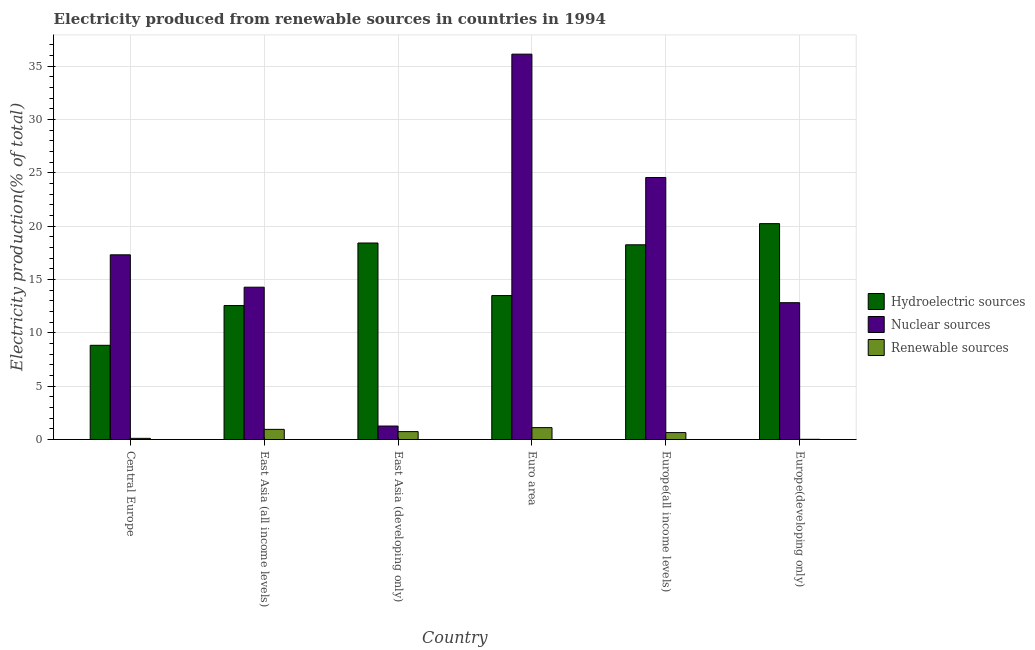How many different coloured bars are there?
Provide a short and direct response. 3. How many groups of bars are there?
Your response must be concise. 6. Are the number of bars per tick equal to the number of legend labels?
Provide a short and direct response. Yes. Are the number of bars on each tick of the X-axis equal?
Give a very brief answer. Yes. How many bars are there on the 2nd tick from the left?
Your answer should be compact. 3. What is the label of the 5th group of bars from the left?
Give a very brief answer. Europe(all income levels). What is the percentage of electricity produced by nuclear sources in East Asia (all income levels)?
Ensure brevity in your answer.  14.28. Across all countries, what is the maximum percentage of electricity produced by nuclear sources?
Your answer should be compact. 36.13. Across all countries, what is the minimum percentage of electricity produced by hydroelectric sources?
Ensure brevity in your answer.  8.83. In which country was the percentage of electricity produced by nuclear sources minimum?
Provide a short and direct response. East Asia (developing only). What is the total percentage of electricity produced by renewable sources in the graph?
Give a very brief answer. 3.59. What is the difference between the percentage of electricity produced by nuclear sources in East Asia (developing only) and that in Euro area?
Provide a succinct answer. -34.87. What is the difference between the percentage of electricity produced by nuclear sources in East Asia (developing only) and the percentage of electricity produced by renewable sources in East Asia (all income levels)?
Ensure brevity in your answer.  0.31. What is the average percentage of electricity produced by hydroelectric sources per country?
Give a very brief answer. 15.3. What is the difference between the percentage of electricity produced by nuclear sources and percentage of electricity produced by hydroelectric sources in Europe(developing only)?
Offer a very short reply. -7.41. What is the ratio of the percentage of electricity produced by renewable sources in Central Europe to that in Europe(developing only)?
Your response must be concise. 5.5. What is the difference between the highest and the second highest percentage of electricity produced by renewable sources?
Provide a succinct answer. 0.16. What is the difference between the highest and the lowest percentage of electricity produced by renewable sources?
Provide a short and direct response. 1.09. In how many countries, is the percentage of electricity produced by nuclear sources greater than the average percentage of electricity produced by nuclear sources taken over all countries?
Offer a terse response. 2. What does the 3rd bar from the left in East Asia (all income levels) represents?
Keep it short and to the point. Renewable sources. What does the 1st bar from the right in Central Europe represents?
Your answer should be compact. Renewable sources. Is it the case that in every country, the sum of the percentage of electricity produced by hydroelectric sources and percentage of electricity produced by nuclear sources is greater than the percentage of electricity produced by renewable sources?
Provide a short and direct response. Yes. Are all the bars in the graph horizontal?
Offer a terse response. No. Are the values on the major ticks of Y-axis written in scientific E-notation?
Ensure brevity in your answer.  No. Does the graph contain any zero values?
Offer a terse response. No. Does the graph contain grids?
Make the answer very short. Yes. Where does the legend appear in the graph?
Provide a succinct answer. Center right. How are the legend labels stacked?
Make the answer very short. Vertical. What is the title of the graph?
Ensure brevity in your answer.  Electricity produced from renewable sources in countries in 1994. Does "Domestic economy" appear as one of the legend labels in the graph?
Your response must be concise. No. What is the label or title of the Y-axis?
Provide a succinct answer. Electricity production(% of total). What is the Electricity production(% of total) of Hydroelectric sources in Central Europe?
Make the answer very short. 8.83. What is the Electricity production(% of total) of Nuclear sources in Central Europe?
Offer a very short reply. 17.32. What is the Electricity production(% of total) in Renewable sources in Central Europe?
Offer a very short reply. 0.11. What is the Electricity production(% of total) of Hydroelectric sources in East Asia (all income levels)?
Your answer should be very brief. 12.56. What is the Electricity production(% of total) of Nuclear sources in East Asia (all income levels)?
Keep it short and to the point. 14.28. What is the Electricity production(% of total) in Renewable sources in East Asia (all income levels)?
Offer a terse response. 0.95. What is the Electricity production(% of total) in Hydroelectric sources in East Asia (developing only)?
Provide a succinct answer. 18.43. What is the Electricity production(% of total) of Nuclear sources in East Asia (developing only)?
Your answer should be compact. 1.26. What is the Electricity production(% of total) of Renewable sources in East Asia (developing only)?
Offer a terse response. 0.74. What is the Electricity production(% of total) in Hydroelectric sources in Euro area?
Make the answer very short. 13.5. What is the Electricity production(% of total) in Nuclear sources in Euro area?
Give a very brief answer. 36.13. What is the Electricity production(% of total) of Renewable sources in Euro area?
Offer a terse response. 1.11. What is the Electricity production(% of total) of Hydroelectric sources in Europe(all income levels)?
Offer a terse response. 18.26. What is the Electricity production(% of total) of Nuclear sources in Europe(all income levels)?
Ensure brevity in your answer.  24.57. What is the Electricity production(% of total) in Renewable sources in Europe(all income levels)?
Offer a very short reply. 0.65. What is the Electricity production(% of total) in Hydroelectric sources in Europe(developing only)?
Keep it short and to the point. 20.24. What is the Electricity production(% of total) of Nuclear sources in Europe(developing only)?
Ensure brevity in your answer.  12.83. What is the Electricity production(% of total) of Renewable sources in Europe(developing only)?
Provide a short and direct response. 0.02. Across all countries, what is the maximum Electricity production(% of total) in Hydroelectric sources?
Offer a terse response. 20.24. Across all countries, what is the maximum Electricity production(% of total) of Nuclear sources?
Your response must be concise. 36.13. Across all countries, what is the maximum Electricity production(% of total) in Renewable sources?
Provide a succinct answer. 1.11. Across all countries, what is the minimum Electricity production(% of total) in Hydroelectric sources?
Provide a short and direct response. 8.83. Across all countries, what is the minimum Electricity production(% of total) of Nuclear sources?
Your response must be concise. 1.26. Across all countries, what is the minimum Electricity production(% of total) in Renewable sources?
Keep it short and to the point. 0.02. What is the total Electricity production(% of total) in Hydroelectric sources in the graph?
Provide a short and direct response. 91.82. What is the total Electricity production(% of total) in Nuclear sources in the graph?
Your response must be concise. 106.4. What is the total Electricity production(% of total) of Renewable sources in the graph?
Your answer should be compact. 3.59. What is the difference between the Electricity production(% of total) in Hydroelectric sources in Central Europe and that in East Asia (all income levels)?
Make the answer very short. -3.73. What is the difference between the Electricity production(% of total) of Nuclear sources in Central Europe and that in East Asia (all income levels)?
Keep it short and to the point. 3.04. What is the difference between the Electricity production(% of total) of Renewable sources in Central Europe and that in East Asia (all income levels)?
Give a very brief answer. -0.84. What is the difference between the Electricity production(% of total) in Hydroelectric sources in Central Europe and that in East Asia (developing only)?
Keep it short and to the point. -9.59. What is the difference between the Electricity production(% of total) of Nuclear sources in Central Europe and that in East Asia (developing only)?
Provide a succinct answer. 16.05. What is the difference between the Electricity production(% of total) of Renewable sources in Central Europe and that in East Asia (developing only)?
Your answer should be compact. -0.63. What is the difference between the Electricity production(% of total) in Hydroelectric sources in Central Europe and that in Euro area?
Give a very brief answer. -4.66. What is the difference between the Electricity production(% of total) in Nuclear sources in Central Europe and that in Euro area?
Keep it short and to the point. -18.82. What is the difference between the Electricity production(% of total) in Renewable sources in Central Europe and that in Euro area?
Provide a succinct answer. -1.01. What is the difference between the Electricity production(% of total) in Hydroelectric sources in Central Europe and that in Europe(all income levels)?
Provide a short and direct response. -9.43. What is the difference between the Electricity production(% of total) in Nuclear sources in Central Europe and that in Europe(all income levels)?
Give a very brief answer. -7.25. What is the difference between the Electricity production(% of total) of Renewable sources in Central Europe and that in Europe(all income levels)?
Make the answer very short. -0.54. What is the difference between the Electricity production(% of total) of Hydroelectric sources in Central Europe and that in Europe(developing only)?
Keep it short and to the point. -11.41. What is the difference between the Electricity production(% of total) of Nuclear sources in Central Europe and that in Europe(developing only)?
Ensure brevity in your answer.  4.49. What is the difference between the Electricity production(% of total) of Renewable sources in Central Europe and that in Europe(developing only)?
Your response must be concise. 0.09. What is the difference between the Electricity production(% of total) in Hydroelectric sources in East Asia (all income levels) and that in East Asia (developing only)?
Provide a short and direct response. -5.86. What is the difference between the Electricity production(% of total) of Nuclear sources in East Asia (all income levels) and that in East Asia (developing only)?
Offer a terse response. 13.02. What is the difference between the Electricity production(% of total) in Renewable sources in East Asia (all income levels) and that in East Asia (developing only)?
Offer a terse response. 0.21. What is the difference between the Electricity production(% of total) in Hydroelectric sources in East Asia (all income levels) and that in Euro area?
Your answer should be very brief. -0.94. What is the difference between the Electricity production(% of total) of Nuclear sources in East Asia (all income levels) and that in Euro area?
Your answer should be compact. -21.85. What is the difference between the Electricity production(% of total) in Renewable sources in East Asia (all income levels) and that in Euro area?
Provide a short and direct response. -0.16. What is the difference between the Electricity production(% of total) of Hydroelectric sources in East Asia (all income levels) and that in Europe(all income levels)?
Your answer should be very brief. -5.7. What is the difference between the Electricity production(% of total) of Nuclear sources in East Asia (all income levels) and that in Europe(all income levels)?
Provide a short and direct response. -10.29. What is the difference between the Electricity production(% of total) of Renewable sources in East Asia (all income levels) and that in Europe(all income levels)?
Provide a short and direct response. 0.3. What is the difference between the Electricity production(% of total) in Hydroelectric sources in East Asia (all income levels) and that in Europe(developing only)?
Offer a terse response. -7.68. What is the difference between the Electricity production(% of total) in Nuclear sources in East Asia (all income levels) and that in Europe(developing only)?
Make the answer very short. 1.45. What is the difference between the Electricity production(% of total) of Renewable sources in East Asia (all income levels) and that in Europe(developing only)?
Provide a succinct answer. 0.93. What is the difference between the Electricity production(% of total) in Hydroelectric sources in East Asia (developing only) and that in Euro area?
Provide a short and direct response. 4.93. What is the difference between the Electricity production(% of total) in Nuclear sources in East Asia (developing only) and that in Euro area?
Provide a succinct answer. -34.87. What is the difference between the Electricity production(% of total) of Renewable sources in East Asia (developing only) and that in Euro area?
Provide a succinct answer. -0.37. What is the difference between the Electricity production(% of total) in Hydroelectric sources in East Asia (developing only) and that in Europe(all income levels)?
Keep it short and to the point. 0.17. What is the difference between the Electricity production(% of total) in Nuclear sources in East Asia (developing only) and that in Europe(all income levels)?
Offer a terse response. -23.3. What is the difference between the Electricity production(% of total) of Renewable sources in East Asia (developing only) and that in Europe(all income levels)?
Provide a short and direct response. 0.09. What is the difference between the Electricity production(% of total) in Hydroelectric sources in East Asia (developing only) and that in Europe(developing only)?
Provide a succinct answer. -1.81. What is the difference between the Electricity production(% of total) of Nuclear sources in East Asia (developing only) and that in Europe(developing only)?
Give a very brief answer. -11.57. What is the difference between the Electricity production(% of total) in Renewable sources in East Asia (developing only) and that in Europe(developing only)?
Give a very brief answer. 0.72. What is the difference between the Electricity production(% of total) of Hydroelectric sources in Euro area and that in Europe(all income levels)?
Ensure brevity in your answer.  -4.76. What is the difference between the Electricity production(% of total) in Nuclear sources in Euro area and that in Europe(all income levels)?
Ensure brevity in your answer.  11.57. What is the difference between the Electricity production(% of total) in Renewable sources in Euro area and that in Europe(all income levels)?
Keep it short and to the point. 0.46. What is the difference between the Electricity production(% of total) of Hydroelectric sources in Euro area and that in Europe(developing only)?
Give a very brief answer. -6.74. What is the difference between the Electricity production(% of total) in Nuclear sources in Euro area and that in Europe(developing only)?
Provide a succinct answer. 23.3. What is the difference between the Electricity production(% of total) of Renewable sources in Euro area and that in Europe(developing only)?
Offer a very short reply. 1.09. What is the difference between the Electricity production(% of total) in Hydroelectric sources in Europe(all income levels) and that in Europe(developing only)?
Provide a succinct answer. -1.98. What is the difference between the Electricity production(% of total) of Nuclear sources in Europe(all income levels) and that in Europe(developing only)?
Ensure brevity in your answer.  11.74. What is the difference between the Electricity production(% of total) in Renewable sources in Europe(all income levels) and that in Europe(developing only)?
Ensure brevity in your answer.  0.63. What is the difference between the Electricity production(% of total) in Hydroelectric sources in Central Europe and the Electricity production(% of total) in Nuclear sources in East Asia (all income levels)?
Your answer should be compact. -5.45. What is the difference between the Electricity production(% of total) in Hydroelectric sources in Central Europe and the Electricity production(% of total) in Renewable sources in East Asia (all income levels)?
Provide a succinct answer. 7.88. What is the difference between the Electricity production(% of total) in Nuclear sources in Central Europe and the Electricity production(% of total) in Renewable sources in East Asia (all income levels)?
Your answer should be compact. 16.37. What is the difference between the Electricity production(% of total) in Hydroelectric sources in Central Europe and the Electricity production(% of total) in Nuclear sources in East Asia (developing only)?
Offer a terse response. 7.57. What is the difference between the Electricity production(% of total) of Hydroelectric sources in Central Europe and the Electricity production(% of total) of Renewable sources in East Asia (developing only)?
Your response must be concise. 8.09. What is the difference between the Electricity production(% of total) of Nuclear sources in Central Europe and the Electricity production(% of total) of Renewable sources in East Asia (developing only)?
Provide a succinct answer. 16.58. What is the difference between the Electricity production(% of total) in Hydroelectric sources in Central Europe and the Electricity production(% of total) in Nuclear sources in Euro area?
Provide a succinct answer. -27.3. What is the difference between the Electricity production(% of total) of Hydroelectric sources in Central Europe and the Electricity production(% of total) of Renewable sources in Euro area?
Provide a succinct answer. 7.72. What is the difference between the Electricity production(% of total) in Nuclear sources in Central Europe and the Electricity production(% of total) in Renewable sources in Euro area?
Your response must be concise. 16.2. What is the difference between the Electricity production(% of total) of Hydroelectric sources in Central Europe and the Electricity production(% of total) of Nuclear sources in Europe(all income levels)?
Offer a terse response. -15.73. What is the difference between the Electricity production(% of total) of Hydroelectric sources in Central Europe and the Electricity production(% of total) of Renewable sources in Europe(all income levels)?
Your answer should be compact. 8.18. What is the difference between the Electricity production(% of total) of Nuclear sources in Central Europe and the Electricity production(% of total) of Renewable sources in Europe(all income levels)?
Your response must be concise. 16.67. What is the difference between the Electricity production(% of total) of Hydroelectric sources in Central Europe and the Electricity production(% of total) of Nuclear sources in Europe(developing only)?
Give a very brief answer. -4. What is the difference between the Electricity production(% of total) of Hydroelectric sources in Central Europe and the Electricity production(% of total) of Renewable sources in Europe(developing only)?
Your response must be concise. 8.81. What is the difference between the Electricity production(% of total) in Nuclear sources in Central Europe and the Electricity production(% of total) in Renewable sources in Europe(developing only)?
Ensure brevity in your answer.  17.3. What is the difference between the Electricity production(% of total) in Hydroelectric sources in East Asia (all income levels) and the Electricity production(% of total) in Nuclear sources in East Asia (developing only)?
Provide a succinct answer. 11.3. What is the difference between the Electricity production(% of total) in Hydroelectric sources in East Asia (all income levels) and the Electricity production(% of total) in Renewable sources in East Asia (developing only)?
Ensure brevity in your answer.  11.82. What is the difference between the Electricity production(% of total) of Nuclear sources in East Asia (all income levels) and the Electricity production(% of total) of Renewable sources in East Asia (developing only)?
Ensure brevity in your answer.  13.54. What is the difference between the Electricity production(% of total) of Hydroelectric sources in East Asia (all income levels) and the Electricity production(% of total) of Nuclear sources in Euro area?
Your answer should be compact. -23.57. What is the difference between the Electricity production(% of total) of Hydroelectric sources in East Asia (all income levels) and the Electricity production(% of total) of Renewable sources in Euro area?
Provide a short and direct response. 11.45. What is the difference between the Electricity production(% of total) in Nuclear sources in East Asia (all income levels) and the Electricity production(% of total) in Renewable sources in Euro area?
Give a very brief answer. 13.17. What is the difference between the Electricity production(% of total) in Hydroelectric sources in East Asia (all income levels) and the Electricity production(% of total) in Nuclear sources in Europe(all income levels)?
Offer a terse response. -12.01. What is the difference between the Electricity production(% of total) in Hydroelectric sources in East Asia (all income levels) and the Electricity production(% of total) in Renewable sources in Europe(all income levels)?
Give a very brief answer. 11.91. What is the difference between the Electricity production(% of total) in Nuclear sources in East Asia (all income levels) and the Electricity production(% of total) in Renewable sources in Europe(all income levels)?
Offer a very short reply. 13.63. What is the difference between the Electricity production(% of total) of Hydroelectric sources in East Asia (all income levels) and the Electricity production(% of total) of Nuclear sources in Europe(developing only)?
Offer a terse response. -0.27. What is the difference between the Electricity production(% of total) in Hydroelectric sources in East Asia (all income levels) and the Electricity production(% of total) in Renewable sources in Europe(developing only)?
Offer a very short reply. 12.54. What is the difference between the Electricity production(% of total) in Nuclear sources in East Asia (all income levels) and the Electricity production(% of total) in Renewable sources in Europe(developing only)?
Your answer should be very brief. 14.26. What is the difference between the Electricity production(% of total) of Hydroelectric sources in East Asia (developing only) and the Electricity production(% of total) of Nuclear sources in Euro area?
Provide a succinct answer. -17.71. What is the difference between the Electricity production(% of total) of Hydroelectric sources in East Asia (developing only) and the Electricity production(% of total) of Renewable sources in Euro area?
Ensure brevity in your answer.  17.31. What is the difference between the Electricity production(% of total) of Nuclear sources in East Asia (developing only) and the Electricity production(% of total) of Renewable sources in Euro area?
Offer a very short reply. 0.15. What is the difference between the Electricity production(% of total) in Hydroelectric sources in East Asia (developing only) and the Electricity production(% of total) in Nuclear sources in Europe(all income levels)?
Keep it short and to the point. -6.14. What is the difference between the Electricity production(% of total) in Hydroelectric sources in East Asia (developing only) and the Electricity production(% of total) in Renewable sources in Europe(all income levels)?
Provide a short and direct response. 17.78. What is the difference between the Electricity production(% of total) of Nuclear sources in East Asia (developing only) and the Electricity production(% of total) of Renewable sources in Europe(all income levels)?
Your answer should be very brief. 0.61. What is the difference between the Electricity production(% of total) of Hydroelectric sources in East Asia (developing only) and the Electricity production(% of total) of Nuclear sources in Europe(developing only)?
Keep it short and to the point. 5.6. What is the difference between the Electricity production(% of total) in Hydroelectric sources in East Asia (developing only) and the Electricity production(% of total) in Renewable sources in Europe(developing only)?
Provide a short and direct response. 18.41. What is the difference between the Electricity production(% of total) in Nuclear sources in East Asia (developing only) and the Electricity production(% of total) in Renewable sources in Europe(developing only)?
Keep it short and to the point. 1.24. What is the difference between the Electricity production(% of total) of Hydroelectric sources in Euro area and the Electricity production(% of total) of Nuclear sources in Europe(all income levels)?
Ensure brevity in your answer.  -11.07. What is the difference between the Electricity production(% of total) of Hydroelectric sources in Euro area and the Electricity production(% of total) of Renewable sources in Europe(all income levels)?
Offer a very short reply. 12.85. What is the difference between the Electricity production(% of total) in Nuclear sources in Euro area and the Electricity production(% of total) in Renewable sources in Europe(all income levels)?
Your answer should be compact. 35.48. What is the difference between the Electricity production(% of total) in Hydroelectric sources in Euro area and the Electricity production(% of total) in Nuclear sources in Europe(developing only)?
Offer a very short reply. 0.67. What is the difference between the Electricity production(% of total) in Hydroelectric sources in Euro area and the Electricity production(% of total) in Renewable sources in Europe(developing only)?
Your answer should be compact. 13.48. What is the difference between the Electricity production(% of total) in Nuclear sources in Euro area and the Electricity production(% of total) in Renewable sources in Europe(developing only)?
Your answer should be compact. 36.11. What is the difference between the Electricity production(% of total) of Hydroelectric sources in Europe(all income levels) and the Electricity production(% of total) of Nuclear sources in Europe(developing only)?
Your answer should be very brief. 5.43. What is the difference between the Electricity production(% of total) of Hydroelectric sources in Europe(all income levels) and the Electricity production(% of total) of Renewable sources in Europe(developing only)?
Ensure brevity in your answer.  18.24. What is the difference between the Electricity production(% of total) in Nuclear sources in Europe(all income levels) and the Electricity production(% of total) in Renewable sources in Europe(developing only)?
Give a very brief answer. 24.55. What is the average Electricity production(% of total) in Hydroelectric sources per country?
Keep it short and to the point. 15.3. What is the average Electricity production(% of total) in Nuclear sources per country?
Your answer should be very brief. 17.73. What is the average Electricity production(% of total) in Renewable sources per country?
Make the answer very short. 0.6. What is the difference between the Electricity production(% of total) in Hydroelectric sources and Electricity production(% of total) in Nuclear sources in Central Europe?
Your answer should be very brief. -8.49. What is the difference between the Electricity production(% of total) of Hydroelectric sources and Electricity production(% of total) of Renewable sources in Central Europe?
Offer a very short reply. 8.72. What is the difference between the Electricity production(% of total) of Nuclear sources and Electricity production(% of total) of Renewable sources in Central Europe?
Your answer should be compact. 17.21. What is the difference between the Electricity production(% of total) of Hydroelectric sources and Electricity production(% of total) of Nuclear sources in East Asia (all income levels)?
Provide a short and direct response. -1.72. What is the difference between the Electricity production(% of total) in Hydroelectric sources and Electricity production(% of total) in Renewable sources in East Asia (all income levels)?
Provide a succinct answer. 11.61. What is the difference between the Electricity production(% of total) in Nuclear sources and Electricity production(% of total) in Renewable sources in East Asia (all income levels)?
Provide a succinct answer. 13.33. What is the difference between the Electricity production(% of total) of Hydroelectric sources and Electricity production(% of total) of Nuclear sources in East Asia (developing only)?
Ensure brevity in your answer.  17.16. What is the difference between the Electricity production(% of total) of Hydroelectric sources and Electricity production(% of total) of Renewable sources in East Asia (developing only)?
Offer a terse response. 17.68. What is the difference between the Electricity production(% of total) in Nuclear sources and Electricity production(% of total) in Renewable sources in East Asia (developing only)?
Keep it short and to the point. 0.52. What is the difference between the Electricity production(% of total) of Hydroelectric sources and Electricity production(% of total) of Nuclear sources in Euro area?
Provide a short and direct response. -22.64. What is the difference between the Electricity production(% of total) in Hydroelectric sources and Electricity production(% of total) in Renewable sources in Euro area?
Your response must be concise. 12.38. What is the difference between the Electricity production(% of total) of Nuclear sources and Electricity production(% of total) of Renewable sources in Euro area?
Give a very brief answer. 35.02. What is the difference between the Electricity production(% of total) of Hydroelectric sources and Electricity production(% of total) of Nuclear sources in Europe(all income levels)?
Your answer should be very brief. -6.31. What is the difference between the Electricity production(% of total) in Hydroelectric sources and Electricity production(% of total) in Renewable sources in Europe(all income levels)?
Keep it short and to the point. 17.61. What is the difference between the Electricity production(% of total) of Nuclear sources and Electricity production(% of total) of Renewable sources in Europe(all income levels)?
Ensure brevity in your answer.  23.92. What is the difference between the Electricity production(% of total) in Hydroelectric sources and Electricity production(% of total) in Nuclear sources in Europe(developing only)?
Provide a short and direct response. 7.41. What is the difference between the Electricity production(% of total) of Hydroelectric sources and Electricity production(% of total) of Renewable sources in Europe(developing only)?
Provide a succinct answer. 20.22. What is the difference between the Electricity production(% of total) in Nuclear sources and Electricity production(% of total) in Renewable sources in Europe(developing only)?
Provide a short and direct response. 12.81. What is the ratio of the Electricity production(% of total) of Hydroelectric sources in Central Europe to that in East Asia (all income levels)?
Give a very brief answer. 0.7. What is the ratio of the Electricity production(% of total) of Nuclear sources in Central Europe to that in East Asia (all income levels)?
Your response must be concise. 1.21. What is the ratio of the Electricity production(% of total) in Renewable sources in Central Europe to that in East Asia (all income levels)?
Ensure brevity in your answer.  0.11. What is the ratio of the Electricity production(% of total) of Hydroelectric sources in Central Europe to that in East Asia (developing only)?
Provide a short and direct response. 0.48. What is the ratio of the Electricity production(% of total) of Nuclear sources in Central Europe to that in East Asia (developing only)?
Offer a very short reply. 13.7. What is the ratio of the Electricity production(% of total) in Renewable sources in Central Europe to that in East Asia (developing only)?
Your answer should be very brief. 0.15. What is the ratio of the Electricity production(% of total) in Hydroelectric sources in Central Europe to that in Euro area?
Offer a very short reply. 0.65. What is the ratio of the Electricity production(% of total) in Nuclear sources in Central Europe to that in Euro area?
Your answer should be compact. 0.48. What is the ratio of the Electricity production(% of total) in Renewable sources in Central Europe to that in Euro area?
Ensure brevity in your answer.  0.1. What is the ratio of the Electricity production(% of total) in Hydroelectric sources in Central Europe to that in Europe(all income levels)?
Your response must be concise. 0.48. What is the ratio of the Electricity production(% of total) of Nuclear sources in Central Europe to that in Europe(all income levels)?
Ensure brevity in your answer.  0.7. What is the ratio of the Electricity production(% of total) in Renewable sources in Central Europe to that in Europe(all income levels)?
Ensure brevity in your answer.  0.17. What is the ratio of the Electricity production(% of total) of Hydroelectric sources in Central Europe to that in Europe(developing only)?
Give a very brief answer. 0.44. What is the ratio of the Electricity production(% of total) of Nuclear sources in Central Europe to that in Europe(developing only)?
Offer a very short reply. 1.35. What is the ratio of the Electricity production(% of total) of Renewable sources in Central Europe to that in Europe(developing only)?
Your answer should be very brief. 5.5. What is the ratio of the Electricity production(% of total) of Hydroelectric sources in East Asia (all income levels) to that in East Asia (developing only)?
Keep it short and to the point. 0.68. What is the ratio of the Electricity production(% of total) in Nuclear sources in East Asia (all income levels) to that in East Asia (developing only)?
Provide a short and direct response. 11.3. What is the ratio of the Electricity production(% of total) in Renewable sources in East Asia (all income levels) to that in East Asia (developing only)?
Offer a very short reply. 1.28. What is the ratio of the Electricity production(% of total) in Hydroelectric sources in East Asia (all income levels) to that in Euro area?
Your response must be concise. 0.93. What is the ratio of the Electricity production(% of total) of Nuclear sources in East Asia (all income levels) to that in Euro area?
Ensure brevity in your answer.  0.4. What is the ratio of the Electricity production(% of total) in Renewable sources in East Asia (all income levels) to that in Euro area?
Offer a very short reply. 0.85. What is the ratio of the Electricity production(% of total) of Hydroelectric sources in East Asia (all income levels) to that in Europe(all income levels)?
Your answer should be very brief. 0.69. What is the ratio of the Electricity production(% of total) in Nuclear sources in East Asia (all income levels) to that in Europe(all income levels)?
Offer a very short reply. 0.58. What is the ratio of the Electricity production(% of total) in Renewable sources in East Asia (all income levels) to that in Europe(all income levels)?
Provide a short and direct response. 1.46. What is the ratio of the Electricity production(% of total) of Hydroelectric sources in East Asia (all income levels) to that in Europe(developing only)?
Give a very brief answer. 0.62. What is the ratio of the Electricity production(% of total) in Nuclear sources in East Asia (all income levels) to that in Europe(developing only)?
Keep it short and to the point. 1.11. What is the ratio of the Electricity production(% of total) of Renewable sources in East Asia (all income levels) to that in Europe(developing only)?
Your answer should be compact. 48.02. What is the ratio of the Electricity production(% of total) of Hydroelectric sources in East Asia (developing only) to that in Euro area?
Ensure brevity in your answer.  1.37. What is the ratio of the Electricity production(% of total) in Nuclear sources in East Asia (developing only) to that in Euro area?
Keep it short and to the point. 0.04. What is the ratio of the Electricity production(% of total) in Renewable sources in East Asia (developing only) to that in Euro area?
Keep it short and to the point. 0.66. What is the ratio of the Electricity production(% of total) in Hydroelectric sources in East Asia (developing only) to that in Europe(all income levels)?
Offer a very short reply. 1.01. What is the ratio of the Electricity production(% of total) of Nuclear sources in East Asia (developing only) to that in Europe(all income levels)?
Your answer should be very brief. 0.05. What is the ratio of the Electricity production(% of total) in Renewable sources in East Asia (developing only) to that in Europe(all income levels)?
Provide a succinct answer. 1.14. What is the ratio of the Electricity production(% of total) in Hydroelectric sources in East Asia (developing only) to that in Europe(developing only)?
Provide a short and direct response. 0.91. What is the ratio of the Electricity production(% of total) in Nuclear sources in East Asia (developing only) to that in Europe(developing only)?
Provide a short and direct response. 0.1. What is the ratio of the Electricity production(% of total) of Renewable sources in East Asia (developing only) to that in Europe(developing only)?
Offer a very short reply. 37.4. What is the ratio of the Electricity production(% of total) of Hydroelectric sources in Euro area to that in Europe(all income levels)?
Provide a succinct answer. 0.74. What is the ratio of the Electricity production(% of total) of Nuclear sources in Euro area to that in Europe(all income levels)?
Offer a terse response. 1.47. What is the ratio of the Electricity production(% of total) of Renewable sources in Euro area to that in Europe(all income levels)?
Ensure brevity in your answer.  1.71. What is the ratio of the Electricity production(% of total) in Hydroelectric sources in Euro area to that in Europe(developing only)?
Keep it short and to the point. 0.67. What is the ratio of the Electricity production(% of total) in Nuclear sources in Euro area to that in Europe(developing only)?
Your answer should be very brief. 2.82. What is the ratio of the Electricity production(% of total) in Renewable sources in Euro area to that in Europe(developing only)?
Offer a very short reply. 56.25. What is the ratio of the Electricity production(% of total) in Hydroelectric sources in Europe(all income levels) to that in Europe(developing only)?
Ensure brevity in your answer.  0.9. What is the ratio of the Electricity production(% of total) in Nuclear sources in Europe(all income levels) to that in Europe(developing only)?
Keep it short and to the point. 1.91. What is the ratio of the Electricity production(% of total) in Renewable sources in Europe(all income levels) to that in Europe(developing only)?
Ensure brevity in your answer.  32.82. What is the difference between the highest and the second highest Electricity production(% of total) of Hydroelectric sources?
Your answer should be compact. 1.81. What is the difference between the highest and the second highest Electricity production(% of total) in Nuclear sources?
Provide a short and direct response. 11.57. What is the difference between the highest and the second highest Electricity production(% of total) in Renewable sources?
Provide a succinct answer. 0.16. What is the difference between the highest and the lowest Electricity production(% of total) of Hydroelectric sources?
Your answer should be compact. 11.41. What is the difference between the highest and the lowest Electricity production(% of total) of Nuclear sources?
Your answer should be compact. 34.87. What is the difference between the highest and the lowest Electricity production(% of total) in Renewable sources?
Your answer should be compact. 1.09. 